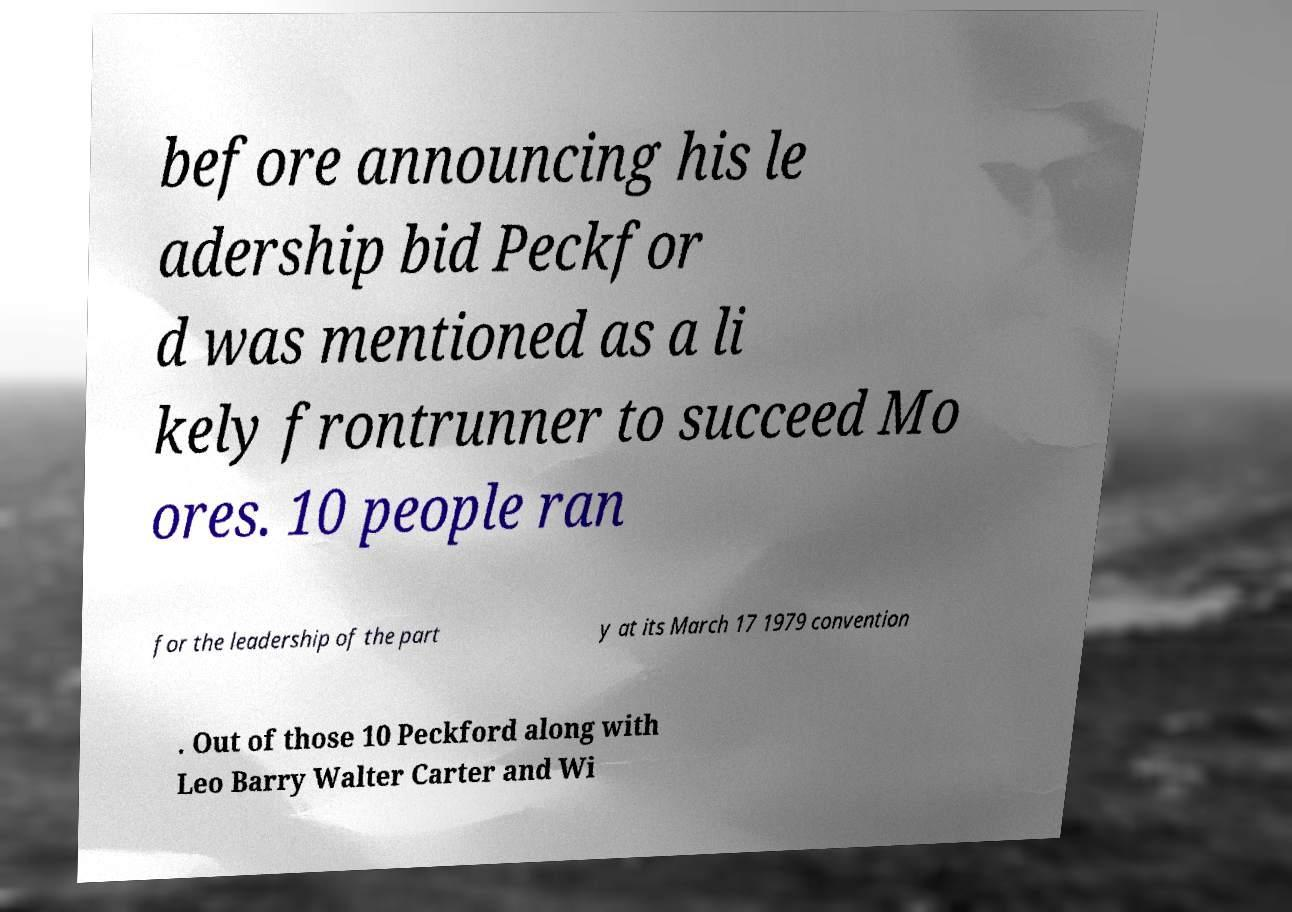For documentation purposes, I need the text within this image transcribed. Could you provide that? before announcing his le adership bid Peckfor d was mentioned as a li kely frontrunner to succeed Mo ores. 10 people ran for the leadership of the part y at its March 17 1979 convention . Out of those 10 Peckford along with Leo Barry Walter Carter and Wi 